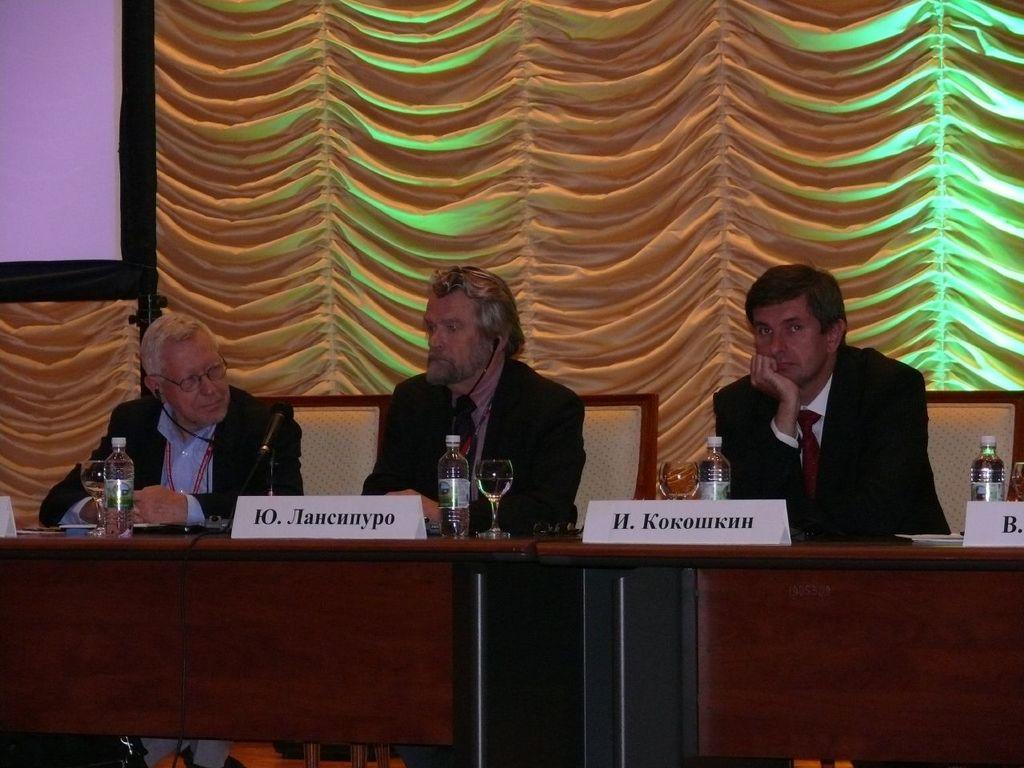In one or two sentences, can you explain what this image depicts? In the foreground of this picture, there is a table on which bottles, glasses, name boards and few paper on it. In the background, there are three men sitting on the chairs, a curtain and a screen. 